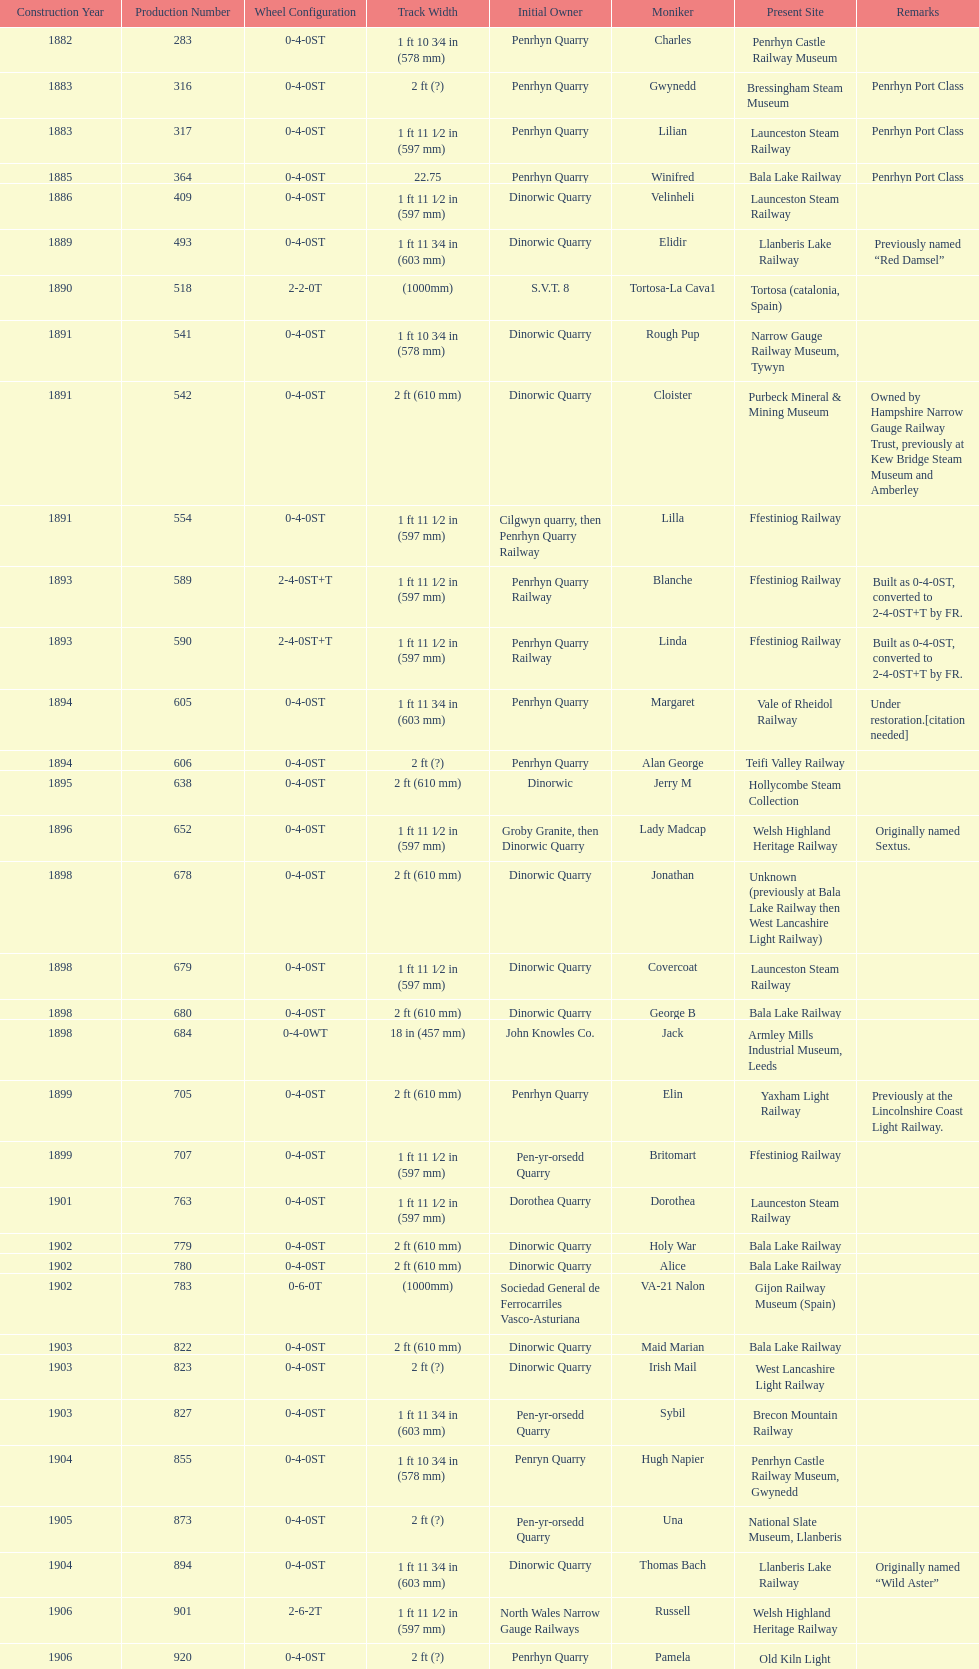Which original owner had the most locomotives? Penrhyn Quarry. 